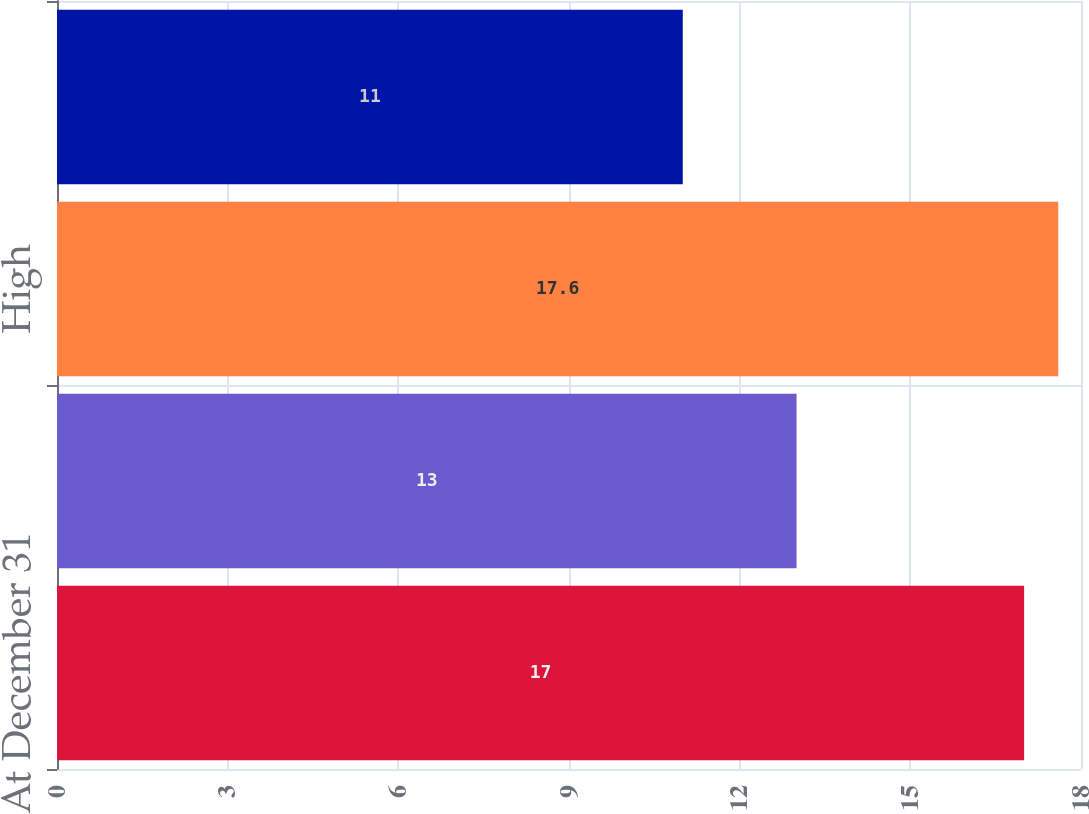Convert chart. <chart><loc_0><loc_0><loc_500><loc_500><bar_chart><fcel>At December 31<fcel>Average<fcel>High<fcel>Low<nl><fcel>17<fcel>13<fcel>17.6<fcel>11<nl></chart> 